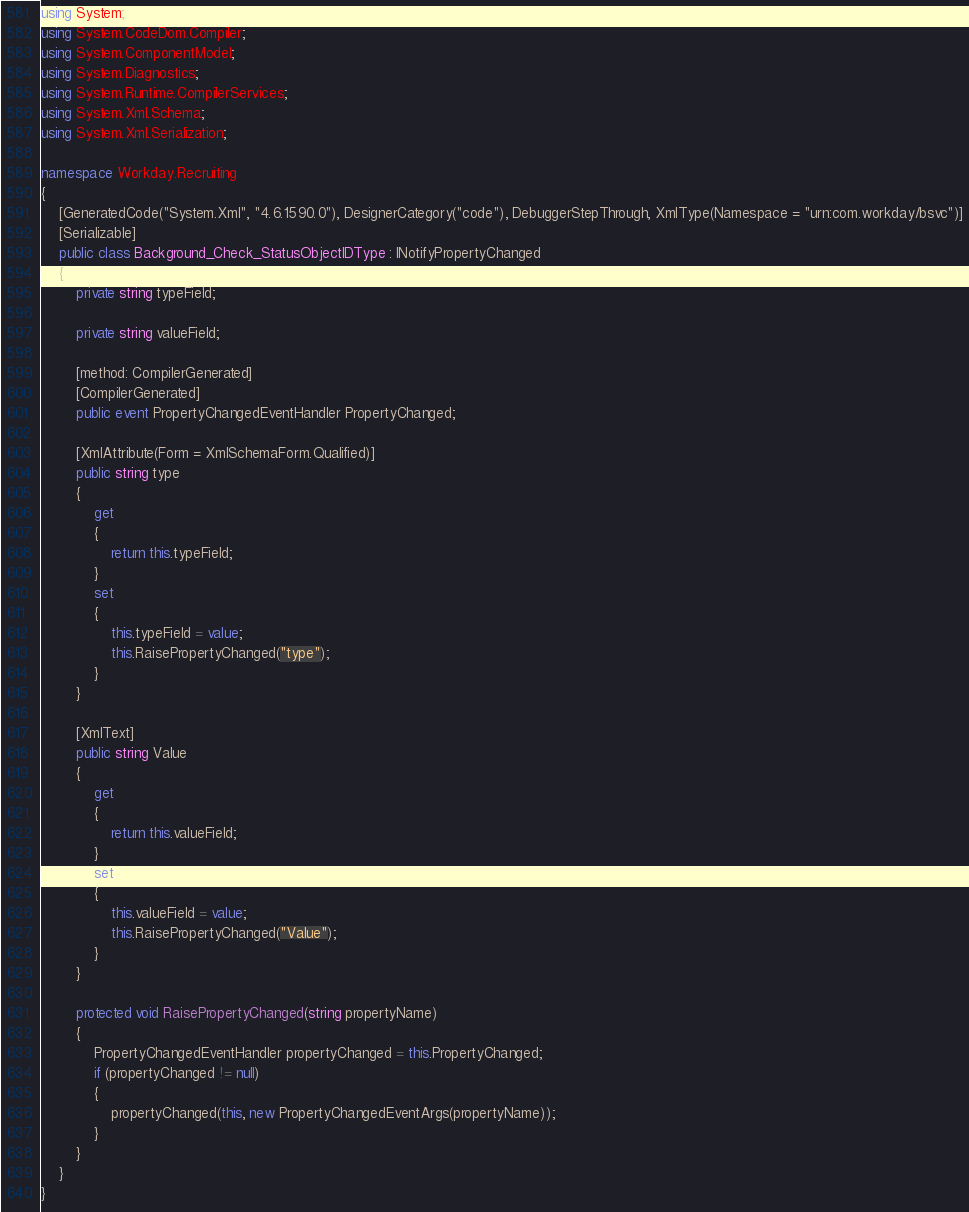<code> <loc_0><loc_0><loc_500><loc_500><_C#_>using System;
using System.CodeDom.Compiler;
using System.ComponentModel;
using System.Diagnostics;
using System.Runtime.CompilerServices;
using System.Xml.Schema;
using System.Xml.Serialization;

namespace Workday.Recruiting
{
	[GeneratedCode("System.Xml", "4.6.1590.0"), DesignerCategory("code"), DebuggerStepThrough, XmlType(Namespace = "urn:com.workday/bsvc")]
	[Serializable]
	public class Background_Check_StatusObjectIDType : INotifyPropertyChanged
	{
		private string typeField;

		private string valueField;

		[method: CompilerGenerated]
		[CompilerGenerated]
		public event PropertyChangedEventHandler PropertyChanged;

		[XmlAttribute(Form = XmlSchemaForm.Qualified)]
		public string type
		{
			get
			{
				return this.typeField;
			}
			set
			{
				this.typeField = value;
				this.RaisePropertyChanged("type");
			}
		}

		[XmlText]
		public string Value
		{
			get
			{
				return this.valueField;
			}
			set
			{
				this.valueField = value;
				this.RaisePropertyChanged("Value");
			}
		}

		protected void RaisePropertyChanged(string propertyName)
		{
			PropertyChangedEventHandler propertyChanged = this.PropertyChanged;
			if (propertyChanged != null)
			{
				propertyChanged(this, new PropertyChangedEventArgs(propertyName));
			}
		}
	}
}
</code> 